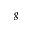Convert formula to latex. <formula><loc_0><loc_0><loc_500><loc_500>_ { g }</formula> 